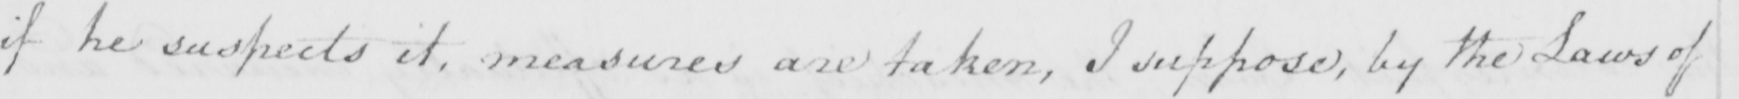Can you read and transcribe this handwriting? if he suspects it , measures are taken , I suppose , by the Laws of 